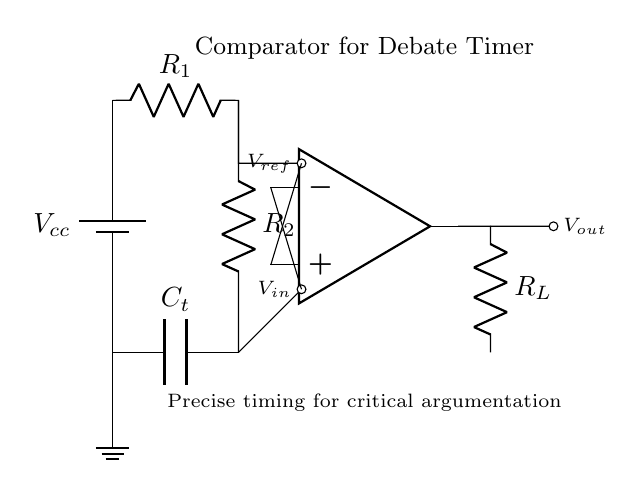What is the component labeled R1? R1 is a resistor in the circuit diagram. It is part of the input voltage divider supplying the reference voltage.
Answer: Resistor What does the output voltage represent in this circuit? The output voltage is the result of the comparison made by the operational amplifier; it indicates whether the input voltage is above or below the reference voltage.
Answer: Comparator result How many capacitors are present in the circuit? There is one capacitor labeled C_t, which is connected to the ground and part of the timing function in the comparator circuit.
Answer: One What does the symbol connected at the top of the operational amplifier denote? The symbol denotes the non-inverting input of the operational amplifier, which receives the reference voltage input from the voltage divider.
Answer: Non-inverting input When the input voltage exceeds the reference voltage, what happens to the output voltage? When the input voltage exceeds the reference voltage, the output voltage of the comparator will be driven to the positive supply voltage level (Vcc).
Answer: High What is the primary function of the timing capacitor C_t? The primary function of the timing capacitor C_t is to create a delay in the circuit by controlling the charging and discharging time, thereby timing the debate rounds.
Answer: Timing What type of circuit is illustrated in the diagram? The circuit is an analog comparator circuit, which compares two input voltages and outputs a signal based on the comparison.
Answer: Comparator circuit 